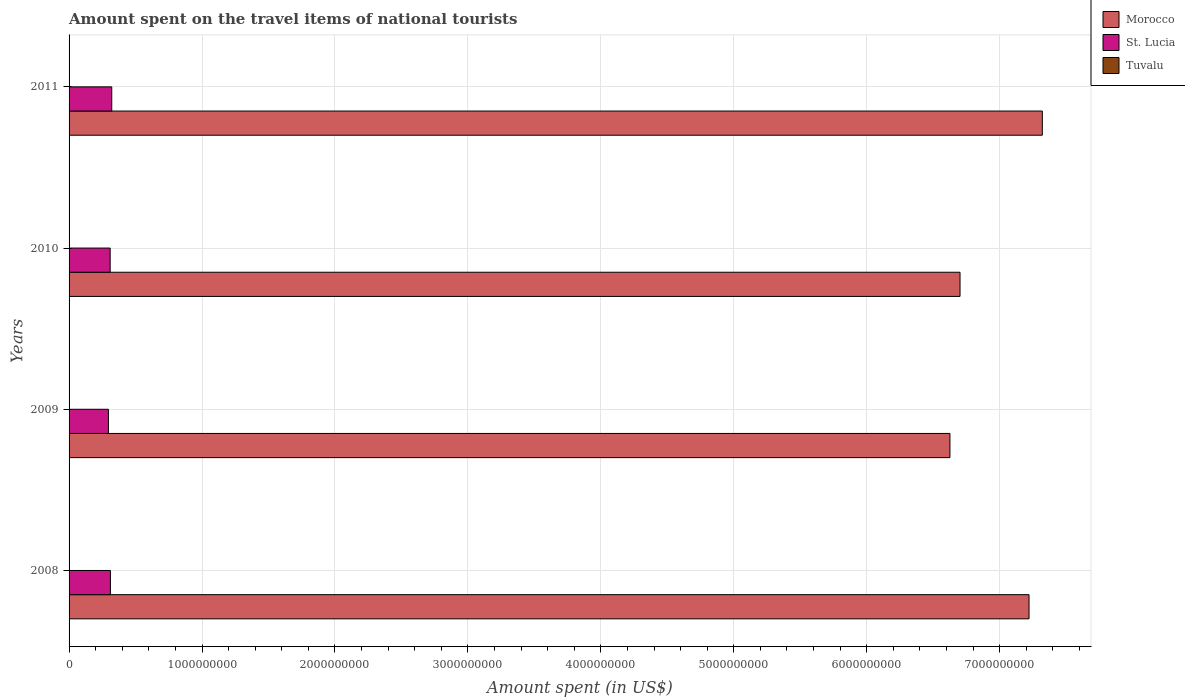How many different coloured bars are there?
Ensure brevity in your answer.  3. Are the number of bars per tick equal to the number of legend labels?
Ensure brevity in your answer.  Yes. Are the number of bars on each tick of the Y-axis equal?
Your response must be concise. Yes. How many bars are there on the 2nd tick from the top?
Offer a terse response. 3. In how many cases, is the number of bars for a given year not equal to the number of legend labels?
Your answer should be very brief. 0. What is the amount spent on the travel items of national tourists in Tuvalu in 2008?
Offer a terse response. 1.87e+06. Across all years, what is the maximum amount spent on the travel items of national tourists in Morocco?
Keep it short and to the point. 7.32e+09. Across all years, what is the minimum amount spent on the travel items of national tourists in Morocco?
Your answer should be compact. 6.63e+09. In which year was the amount spent on the travel items of national tourists in St. Lucia maximum?
Offer a terse response. 2011. In which year was the amount spent on the travel items of national tourists in Morocco minimum?
Offer a very short reply. 2009. What is the total amount spent on the travel items of national tourists in Tuvalu in the graph?
Offer a very short reply. 8.19e+06. What is the difference between the amount spent on the travel items of national tourists in Tuvalu in 2008 and that in 2009?
Your response must be concise. 3.40e+05. What is the difference between the amount spent on the travel items of national tourists in Tuvalu in 2010 and the amount spent on the travel items of national tourists in St. Lucia in 2011?
Ensure brevity in your answer.  -3.19e+08. What is the average amount spent on the travel items of national tourists in St. Lucia per year?
Give a very brief answer. 3.09e+08. In the year 2011, what is the difference between the amount spent on the travel items of national tourists in St. Lucia and amount spent on the travel items of national tourists in Morocco?
Provide a succinct answer. -7.00e+09. What is the ratio of the amount spent on the travel items of national tourists in St. Lucia in 2008 to that in 2011?
Provide a succinct answer. 0.97. Is the amount spent on the travel items of national tourists in Tuvalu in 2008 less than that in 2011?
Give a very brief answer. Yes. What is the difference between the highest and the lowest amount spent on the travel items of national tourists in Morocco?
Make the answer very short. 6.95e+08. Is the sum of the amount spent on the travel items of national tourists in Tuvalu in 2009 and 2011 greater than the maximum amount spent on the travel items of national tourists in Morocco across all years?
Your response must be concise. No. What does the 1st bar from the top in 2010 represents?
Ensure brevity in your answer.  Tuvalu. What does the 3rd bar from the bottom in 2010 represents?
Your answer should be compact. Tuvalu. Is it the case that in every year, the sum of the amount spent on the travel items of national tourists in St. Lucia and amount spent on the travel items of national tourists in Morocco is greater than the amount spent on the travel items of national tourists in Tuvalu?
Your answer should be compact. Yes. What is the difference between two consecutive major ticks on the X-axis?
Provide a succinct answer. 1.00e+09. Are the values on the major ticks of X-axis written in scientific E-notation?
Offer a very short reply. No. Does the graph contain any zero values?
Your response must be concise. No. Does the graph contain grids?
Make the answer very short. Yes. How many legend labels are there?
Provide a short and direct response. 3. How are the legend labels stacked?
Keep it short and to the point. Vertical. What is the title of the graph?
Your answer should be very brief. Amount spent on the travel items of national tourists. What is the label or title of the X-axis?
Ensure brevity in your answer.  Amount spent (in US$). What is the Amount spent (in US$) of Morocco in 2008?
Offer a very short reply. 7.22e+09. What is the Amount spent (in US$) in St. Lucia in 2008?
Ensure brevity in your answer.  3.11e+08. What is the Amount spent (in US$) in Tuvalu in 2008?
Offer a very short reply. 1.87e+06. What is the Amount spent (in US$) of Morocco in 2009?
Your answer should be compact. 6.63e+09. What is the Amount spent (in US$) in St. Lucia in 2009?
Give a very brief answer. 2.96e+08. What is the Amount spent (in US$) of Tuvalu in 2009?
Provide a succinct answer. 1.53e+06. What is the Amount spent (in US$) in Morocco in 2010?
Offer a very short reply. 6.70e+09. What is the Amount spent (in US$) in St. Lucia in 2010?
Provide a short and direct response. 3.09e+08. What is the Amount spent (in US$) of Tuvalu in 2010?
Provide a short and direct response. 2.35e+06. What is the Amount spent (in US$) of Morocco in 2011?
Offer a terse response. 7.32e+09. What is the Amount spent (in US$) in St. Lucia in 2011?
Make the answer very short. 3.21e+08. What is the Amount spent (in US$) in Tuvalu in 2011?
Your answer should be very brief. 2.44e+06. Across all years, what is the maximum Amount spent (in US$) of Morocco?
Provide a short and direct response. 7.32e+09. Across all years, what is the maximum Amount spent (in US$) of St. Lucia?
Ensure brevity in your answer.  3.21e+08. Across all years, what is the maximum Amount spent (in US$) in Tuvalu?
Provide a succinct answer. 2.44e+06. Across all years, what is the minimum Amount spent (in US$) in Morocco?
Give a very brief answer. 6.63e+09. Across all years, what is the minimum Amount spent (in US$) of St. Lucia?
Provide a succinct answer. 2.96e+08. Across all years, what is the minimum Amount spent (in US$) of Tuvalu?
Provide a succinct answer. 1.53e+06. What is the total Amount spent (in US$) in Morocco in the graph?
Make the answer very short. 2.79e+1. What is the total Amount spent (in US$) in St. Lucia in the graph?
Your answer should be compact. 1.24e+09. What is the total Amount spent (in US$) of Tuvalu in the graph?
Offer a very short reply. 8.19e+06. What is the difference between the Amount spent (in US$) of Morocco in 2008 and that in 2009?
Your answer should be compact. 5.95e+08. What is the difference between the Amount spent (in US$) of St. Lucia in 2008 and that in 2009?
Provide a succinct answer. 1.50e+07. What is the difference between the Amount spent (in US$) in Tuvalu in 2008 and that in 2009?
Your response must be concise. 3.40e+05. What is the difference between the Amount spent (in US$) of Morocco in 2008 and that in 2010?
Provide a short and direct response. 5.19e+08. What is the difference between the Amount spent (in US$) in Tuvalu in 2008 and that in 2010?
Your answer should be compact. -4.80e+05. What is the difference between the Amount spent (in US$) in Morocco in 2008 and that in 2011?
Your answer should be very brief. -1.00e+08. What is the difference between the Amount spent (in US$) in St. Lucia in 2008 and that in 2011?
Provide a short and direct response. -1.00e+07. What is the difference between the Amount spent (in US$) in Tuvalu in 2008 and that in 2011?
Keep it short and to the point. -5.70e+05. What is the difference between the Amount spent (in US$) in Morocco in 2009 and that in 2010?
Offer a terse response. -7.60e+07. What is the difference between the Amount spent (in US$) in St. Lucia in 2009 and that in 2010?
Give a very brief answer. -1.30e+07. What is the difference between the Amount spent (in US$) in Tuvalu in 2009 and that in 2010?
Provide a short and direct response. -8.20e+05. What is the difference between the Amount spent (in US$) in Morocco in 2009 and that in 2011?
Ensure brevity in your answer.  -6.95e+08. What is the difference between the Amount spent (in US$) in St. Lucia in 2009 and that in 2011?
Give a very brief answer. -2.50e+07. What is the difference between the Amount spent (in US$) in Tuvalu in 2009 and that in 2011?
Provide a short and direct response. -9.10e+05. What is the difference between the Amount spent (in US$) of Morocco in 2010 and that in 2011?
Offer a terse response. -6.19e+08. What is the difference between the Amount spent (in US$) in St. Lucia in 2010 and that in 2011?
Offer a very short reply. -1.20e+07. What is the difference between the Amount spent (in US$) in Tuvalu in 2010 and that in 2011?
Provide a succinct answer. -9.00e+04. What is the difference between the Amount spent (in US$) of Morocco in 2008 and the Amount spent (in US$) of St. Lucia in 2009?
Ensure brevity in your answer.  6.92e+09. What is the difference between the Amount spent (in US$) in Morocco in 2008 and the Amount spent (in US$) in Tuvalu in 2009?
Provide a short and direct response. 7.22e+09. What is the difference between the Amount spent (in US$) in St. Lucia in 2008 and the Amount spent (in US$) in Tuvalu in 2009?
Your answer should be very brief. 3.09e+08. What is the difference between the Amount spent (in US$) of Morocco in 2008 and the Amount spent (in US$) of St. Lucia in 2010?
Make the answer very short. 6.91e+09. What is the difference between the Amount spent (in US$) of Morocco in 2008 and the Amount spent (in US$) of Tuvalu in 2010?
Provide a succinct answer. 7.22e+09. What is the difference between the Amount spent (in US$) in St. Lucia in 2008 and the Amount spent (in US$) in Tuvalu in 2010?
Your answer should be compact. 3.09e+08. What is the difference between the Amount spent (in US$) of Morocco in 2008 and the Amount spent (in US$) of St. Lucia in 2011?
Your answer should be very brief. 6.90e+09. What is the difference between the Amount spent (in US$) in Morocco in 2008 and the Amount spent (in US$) in Tuvalu in 2011?
Keep it short and to the point. 7.22e+09. What is the difference between the Amount spent (in US$) in St. Lucia in 2008 and the Amount spent (in US$) in Tuvalu in 2011?
Your answer should be compact. 3.09e+08. What is the difference between the Amount spent (in US$) of Morocco in 2009 and the Amount spent (in US$) of St. Lucia in 2010?
Your answer should be very brief. 6.32e+09. What is the difference between the Amount spent (in US$) of Morocco in 2009 and the Amount spent (in US$) of Tuvalu in 2010?
Your answer should be very brief. 6.62e+09. What is the difference between the Amount spent (in US$) of St. Lucia in 2009 and the Amount spent (in US$) of Tuvalu in 2010?
Your answer should be compact. 2.94e+08. What is the difference between the Amount spent (in US$) of Morocco in 2009 and the Amount spent (in US$) of St. Lucia in 2011?
Provide a succinct answer. 6.30e+09. What is the difference between the Amount spent (in US$) in Morocco in 2009 and the Amount spent (in US$) in Tuvalu in 2011?
Offer a very short reply. 6.62e+09. What is the difference between the Amount spent (in US$) in St. Lucia in 2009 and the Amount spent (in US$) in Tuvalu in 2011?
Make the answer very short. 2.94e+08. What is the difference between the Amount spent (in US$) of Morocco in 2010 and the Amount spent (in US$) of St. Lucia in 2011?
Give a very brief answer. 6.38e+09. What is the difference between the Amount spent (in US$) in Morocco in 2010 and the Amount spent (in US$) in Tuvalu in 2011?
Ensure brevity in your answer.  6.70e+09. What is the difference between the Amount spent (in US$) of St. Lucia in 2010 and the Amount spent (in US$) of Tuvalu in 2011?
Provide a short and direct response. 3.07e+08. What is the average Amount spent (in US$) of Morocco per year?
Provide a short and direct response. 6.97e+09. What is the average Amount spent (in US$) of St. Lucia per year?
Your answer should be compact. 3.09e+08. What is the average Amount spent (in US$) in Tuvalu per year?
Make the answer very short. 2.05e+06. In the year 2008, what is the difference between the Amount spent (in US$) in Morocco and Amount spent (in US$) in St. Lucia?
Offer a terse response. 6.91e+09. In the year 2008, what is the difference between the Amount spent (in US$) in Morocco and Amount spent (in US$) in Tuvalu?
Provide a succinct answer. 7.22e+09. In the year 2008, what is the difference between the Amount spent (in US$) of St. Lucia and Amount spent (in US$) of Tuvalu?
Give a very brief answer. 3.09e+08. In the year 2009, what is the difference between the Amount spent (in US$) of Morocco and Amount spent (in US$) of St. Lucia?
Your response must be concise. 6.33e+09. In the year 2009, what is the difference between the Amount spent (in US$) of Morocco and Amount spent (in US$) of Tuvalu?
Your answer should be very brief. 6.62e+09. In the year 2009, what is the difference between the Amount spent (in US$) in St. Lucia and Amount spent (in US$) in Tuvalu?
Your answer should be very brief. 2.94e+08. In the year 2010, what is the difference between the Amount spent (in US$) in Morocco and Amount spent (in US$) in St. Lucia?
Provide a short and direct response. 6.39e+09. In the year 2010, what is the difference between the Amount spent (in US$) in Morocco and Amount spent (in US$) in Tuvalu?
Provide a succinct answer. 6.70e+09. In the year 2010, what is the difference between the Amount spent (in US$) in St. Lucia and Amount spent (in US$) in Tuvalu?
Make the answer very short. 3.07e+08. In the year 2011, what is the difference between the Amount spent (in US$) of Morocco and Amount spent (in US$) of St. Lucia?
Your answer should be very brief. 7.00e+09. In the year 2011, what is the difference between the Amount spent (in US$) of Morocco and Amount spent (in US$) of Tuvalu?
Make the answer very short. 7.32e+09. In the year 2011, what is the difference between the Amount spent (in US$) of St. Lucia and Amount spent (in US$) of Tuvalu?
Provide a succinct answer. 3.19e+08. What is the ratio of the Amount spent (in US$) of Morocco in 2008 to that in 2009?
Keep it short and to the point. 1.09. What is the ratio of the Amount spent (in US$) in St. Lucia in 2008 to that in 2009?
Provide a succinct answer. 1.05. What is the ratio of the Amount spent (in US$) of Tuvalu in 2008 to that in 2009?
Keep it short and to the point. 1.22. What is the ratio of the Amount spent (in US$) in Morocco in 2008 to that in 2010?
Provide a short and direct response. 1.08. What is the ratio of the Amount spent (in US$) in St. Lucia in 2008 to that in 2010?
Your response must be concise. 1.01. What is the ratio of the Amount spent (in US$) in Tuvalu in 2008 to that in 2010?
Give a very brief answer. 0.8. What is the ratio of the Amount spent (in US$) of Morocco in 2008 to that in 2011?
Provide a succinct answer. 0.99. What is the ratio of the Amount spent (in US$) in St. Lucia in 2008 to that in 2011?
Make the answer very short. 0.97. What is the ratio of the Amount spent (in US$) of Tuvalu in 2008 to that in 2011?
Offer a terse response. 0.77. What is the ratio of the Amount spent (in US$) in Morocco in 2009 to that in 2010?
Make the answer very short. 0.99. What is the ratio of the Amount spent (in US$) of St. Lucia in 2009 to that in 2010?
Provide a short and direct response. 0.96. What is the ratio of the Amount spent (in US$) in Tuvalu in 2009 to that in 2010?
Provide a succinct answer. 0.65. What is the ratio of the Amount spent (in US$) of Morocco in 2009 to that in 2011?
Your answer should be compact. 0.91. What is the ratio of the Amount spent (in US$) of St. Lucia in 2009 to that in 2011?
Offer a terse response. 0.92. What is the ratio of the Amount spent (in US$) of Tuvalu in 2009 to that in 2011?
Provide a short and direct response. 0.63. What is the ratio of the Amount spent (in US$) in Morocco in 2010 to that in 2011?
Provide a succinct answer. 0.92. What is the ratio of the Amount spent (in US$) in St. Lucia in 2010 to that in 2011?
Keep it short and to the point. 0.96. What is the ratio of the Amount spent (in US$) in Tuvalu in 2010 to that in 2011?
Your answer should be compact. 0.96. What is the difference between the highest and the second highest Amount spent (in US$) in Morocco?
Give a very brief answer. 1.00e+08. What is the difference between the highest and the second highest Amount spent (in US$) of St. Lucia?
Your answer should be compact. 1.00e+07. What is the difference between the highest and the second highest Amount spent (in US$) of Tuvalu?
Your response must be concise. 9.00e+04. What is the difference between the highest and the lowest Amount spent (in US$) of Morocco?
Make the answer very short. 6.95e+08. What is the difference between the highest and the lowest Amount spent (in US$) of St. Lucia?
Ensure brevity in your answer.  2.50e+07. What is the difference between the highest and the lowest Amount spent (in US$) of Tuvalu?
Keep it short and to the point. 9.10e+05. 